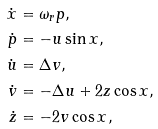<formula> <loc_0><loc_0><loc_500><loc_500>\dot { x } & = \omega _ { r } p , \\ \dot { p } & = - u \sin x , \\ \dot { u } & = \Delta v , \\ \dot { v } & = - \Delta u + 2 z \cos x , \\ \dot { z } & = - 2 v \cos x ,</formula> 